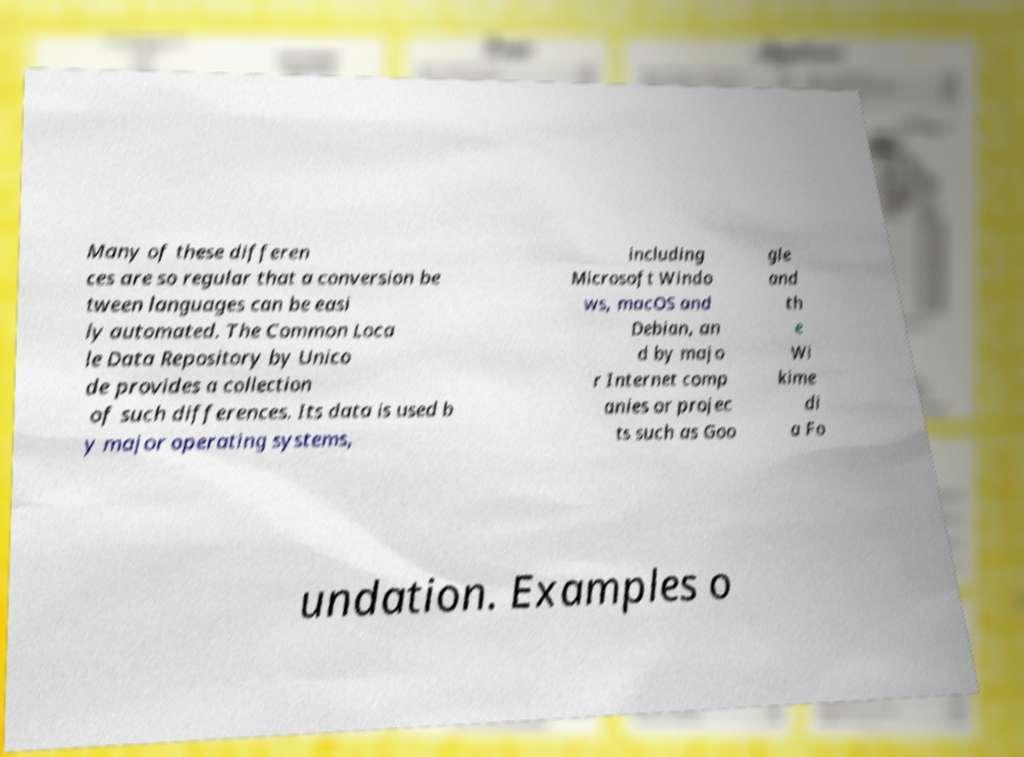Please read and relay the text visible in this image. What does it say? Many of these differen ces are so regular that a conversion be tween languages can be easi ly automated. The Common Loca le Data Repository by Unico de provides a collection of such differences. Its data is used b y major operating systems, including Microsoft Windo ws, macOS and Debian, an d by majo r Internet comp anies or projec ts such as Goo gle and th e Wi kime di a Fo undation. Examples o 